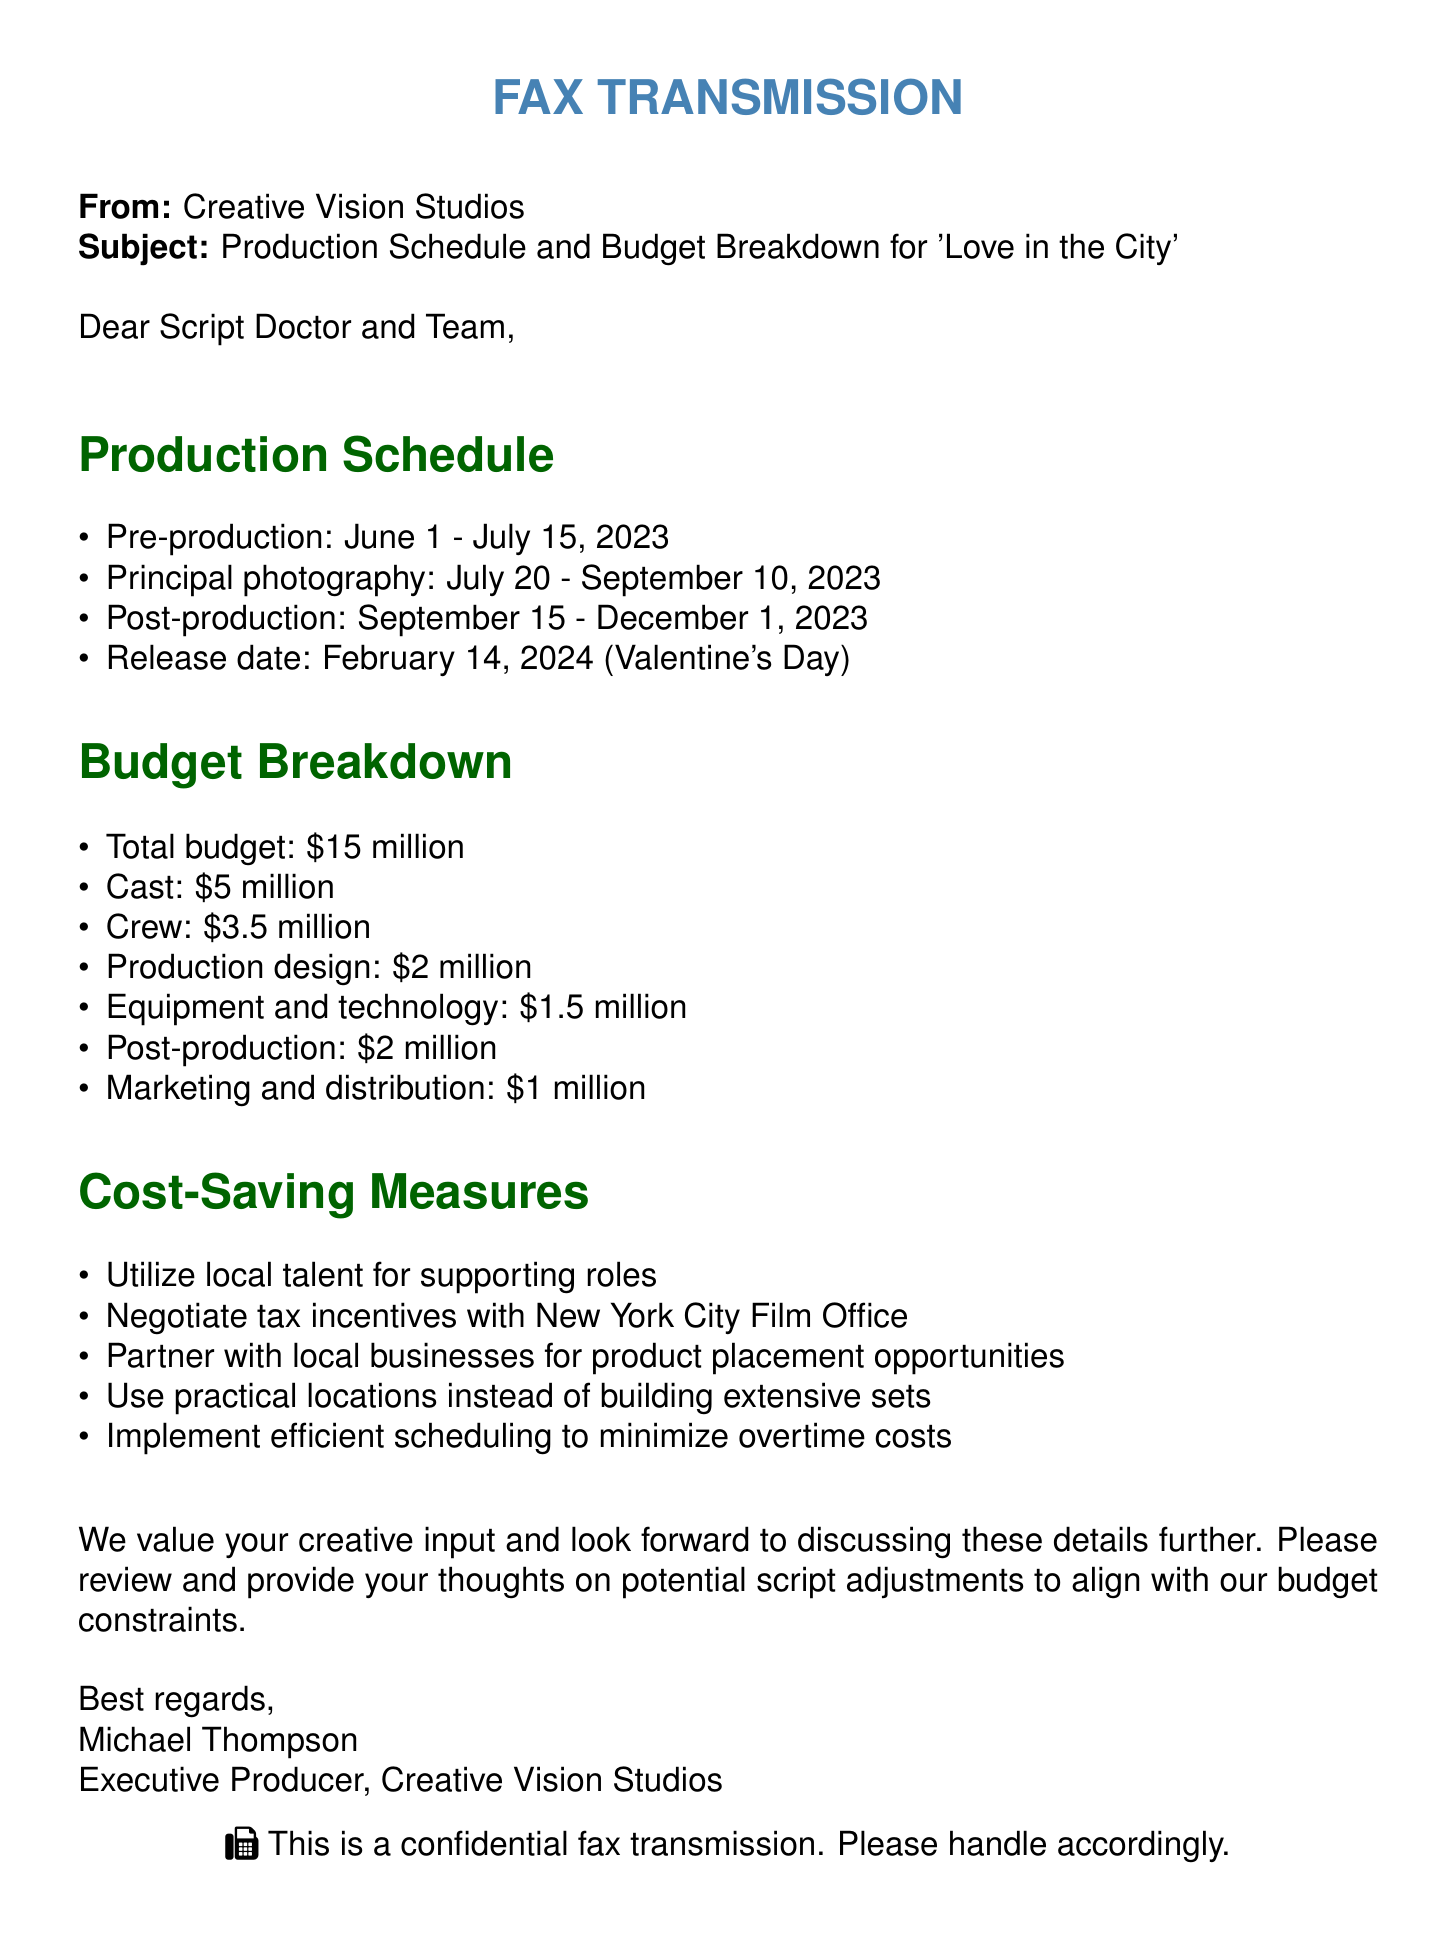what is the total budget? The total budget is stated clearly in the budget breakdown section of the document.
Answer: $15 million what is the release date of the film? The release date is mentioned in the production schedule, marking an important date for marketing efforts.
Answer: February 14, 2024 what is allocated for cast expenses? The budget breakdown specifies the amount allocated for cast expenses, which is one of the main costs in film production.
Answer: $5 million which phase comes after principal photography? The production schedule lists the phases of production, including the order in which they occur.
Answer: Post-production what is one of the cost-saving measures mentioned? The document outlines several cost-saving measures aimed at reducing the overall budget of the film.
Answer: Utilize local talent for supporting roles who is the sender of this fax? The sender's name is included in the closing of the document, providing accountability and context for the communication.
Answer: Michael Thompson how long is the principal photography phase? The production schedule indicates the start and end dates for principal photography, allowing for a calculation of its duration.
Answer: July 20 - September 10, 2023 which city is mentioned for tax incentives? The cost-saving measures include a suggestion to negotiate with a specific city's film office for tax advantages.
Answer: New York City 